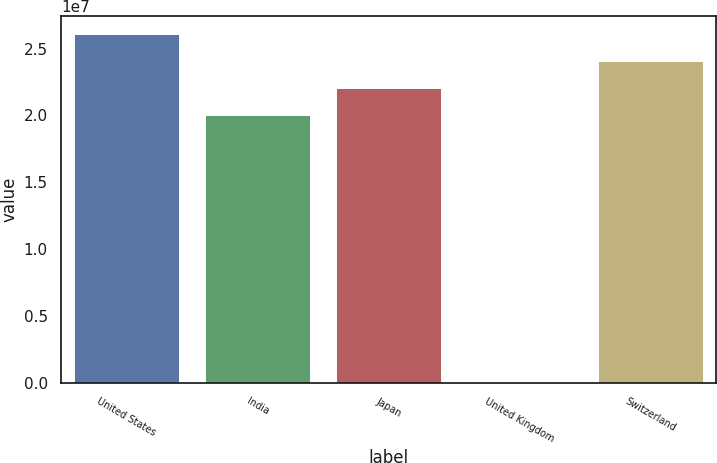Convert chart. <chart><loc_0><loc_0><loc_500><loc_500><bar_chart><fcel>United States<fcel>India<fcel>Japan<fcel>United Kingdom<fcel>Switzerland<nl><fcel>2.6107e+07<fcel>2.0062e+07<fcel>2.2077e+07<fcel>2017<fcel>2.4092e+07<nl></chart> 